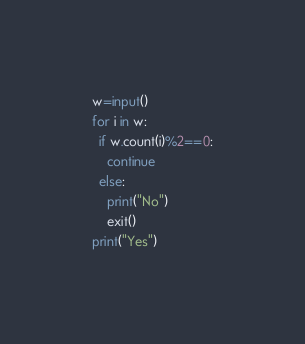<code> <loc_0><loc_0><loc_500><loc_500><_Python_>w=input()
for i in w:
  if w.count(i)%2==0:
    continue
  else:
    print("No")
    exit()
print("Yes")</code> 